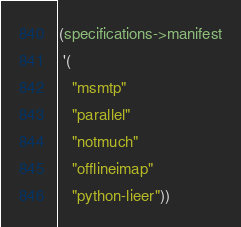<code> <loc_0><loc_0><loc_500><loc_500><_Scheme_>(specifications->manifest
 '(
   "msmtp"
   "parallel"
   "notmuch"
   "offlineimap"
   "python-lieer"))
</code> 